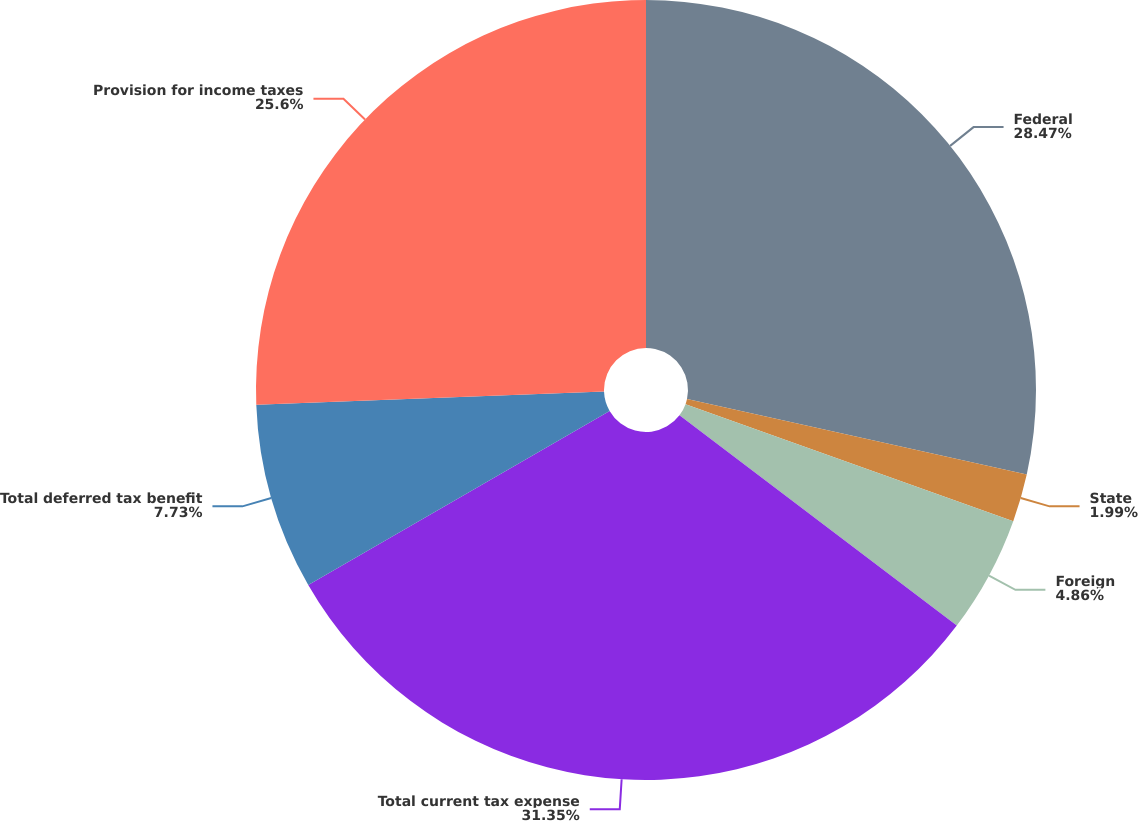Convert chart. <chart><loc_0><loc_0><loc_500><loc_500><pie_chart><fcel>Federal<fcel>State<fcel>Foreign<fcel>Total current tax expense<fcel>Total deferred tax benefit<fcel>Provision for income taxes<nl><fcel>28.47%<fcel>1.99%<fcel>4.86%<fcel>31.34%<fcel>7.73%<fcel>25.6%<nl></chart> 